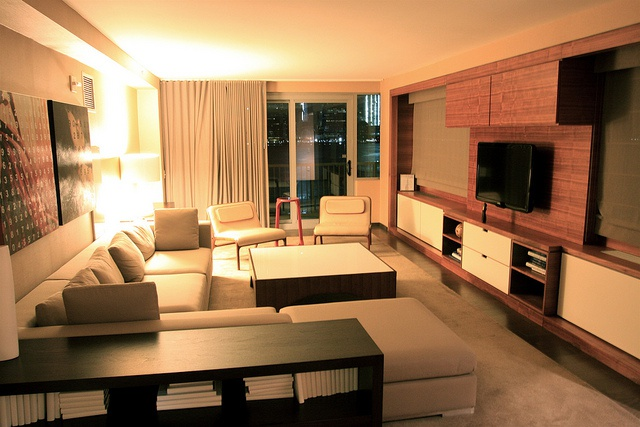Describe the objects in this image and their specific colors. I can see couch in tan, maroon, and khaki tones, book in tan, black, gray, and maroon tones, tv in tan, black, maroon, and brown tones, book in tan, gray, and black tones, and chair in tan, orange, and maroon tones in this image. 